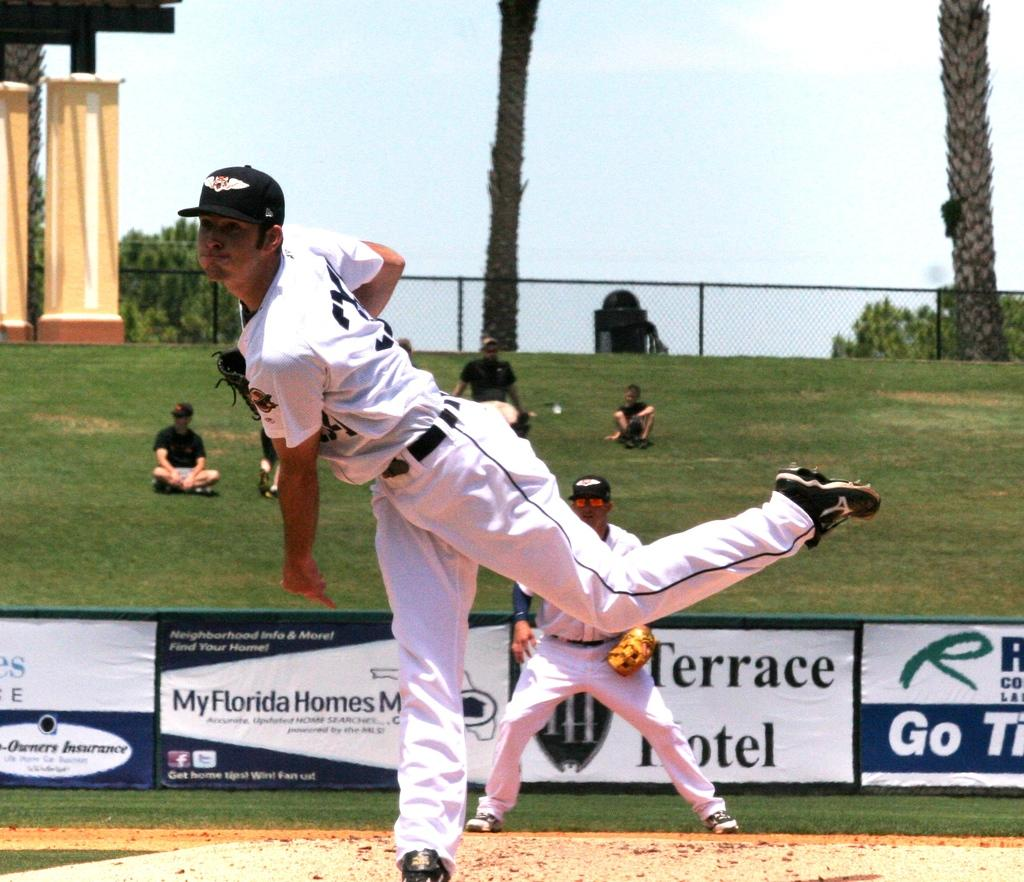<image>
Present a compact description of the photo's key features. Baesball player playing in front of an ad that says My Florida Homes. 